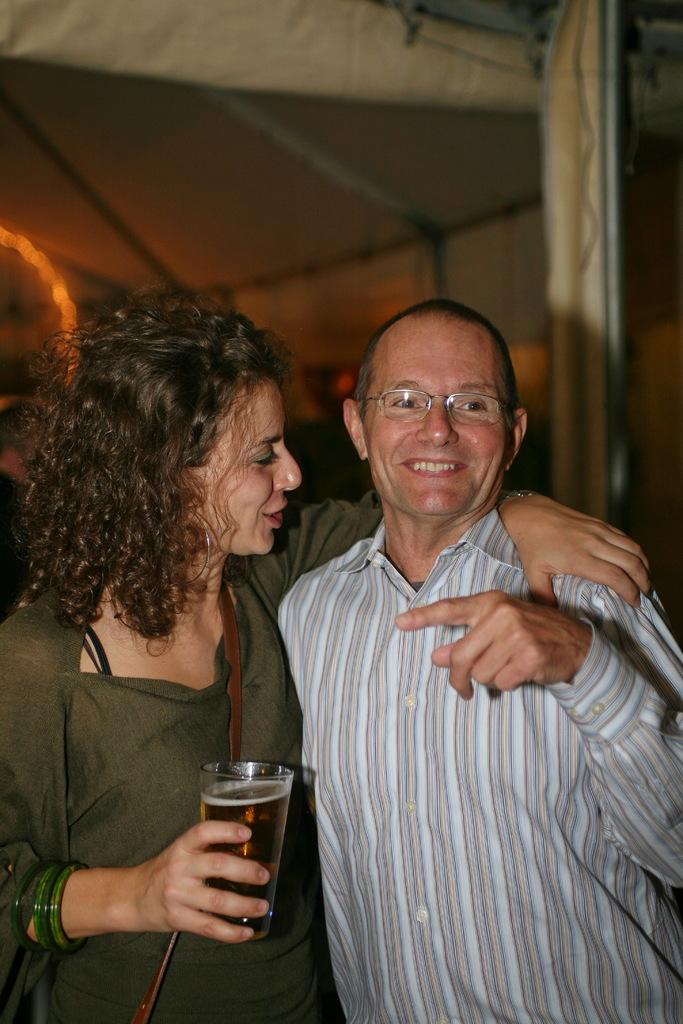Who are the main subjects in the image? There are two people in the center of the image. What is the lady on the left holding? The lady on the left is holding a glass. How is the man next to the lady expressing himself? The man next to the lady is smiling. What can be seen in the background of the image? There is a tent in the background of the image. Can you see the ocean in the background of the image? No, there is no ocean visible in the image; instead, there is a tent in the background. 